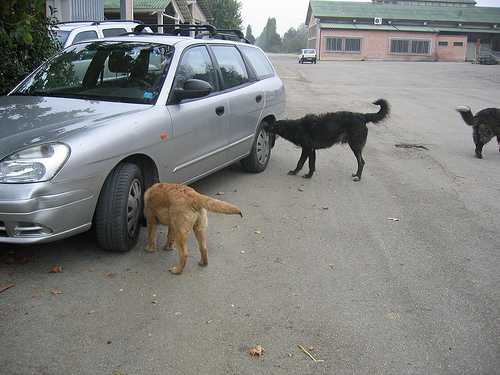<image>
Is the dog in front of the tire? No. The dog is not in front of the tire. The spatial positioning shows a different relationship between these objects. 